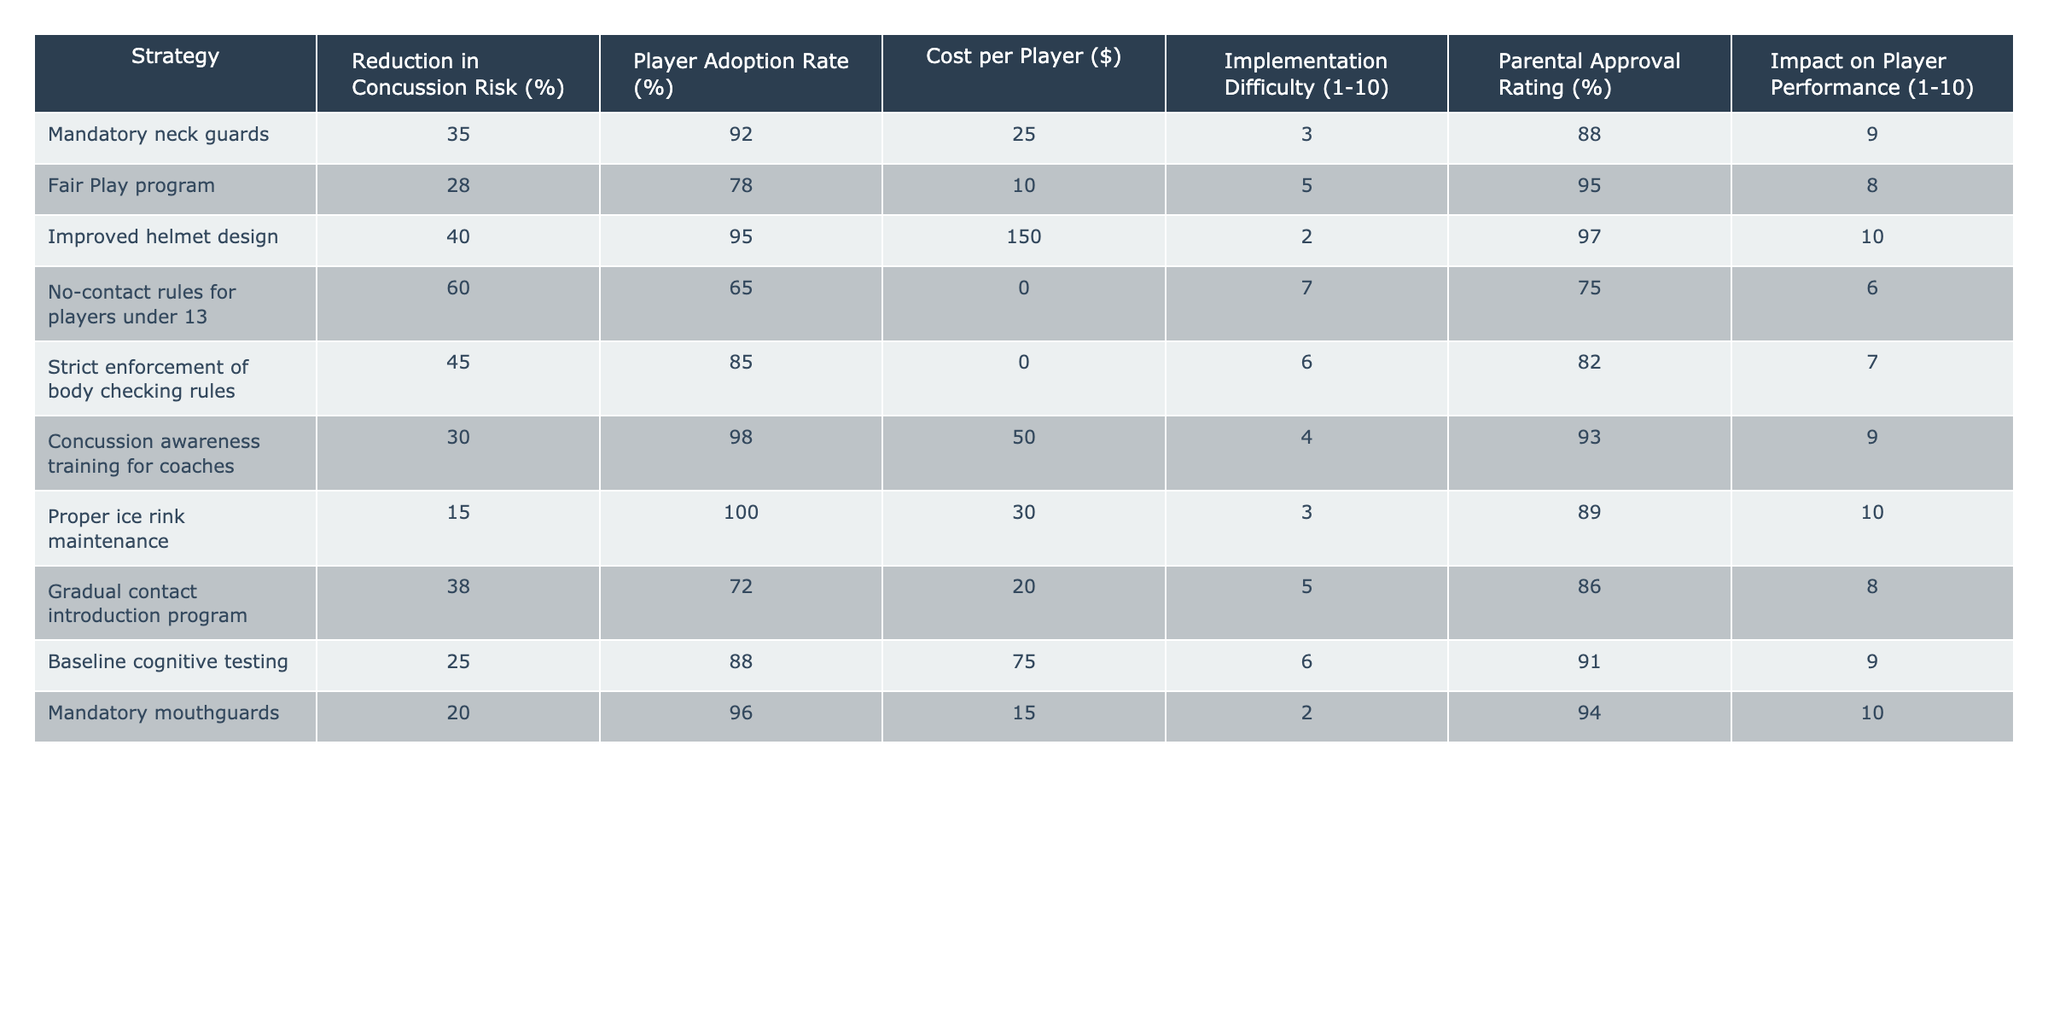What is the concussion risk reduction percentage for improved helmet design? In the table, the "Reduction in Concussion Risk (%)" column shows that improved helmet design has a value of 40%.
Answer: 40% Which strategy has the highest player adoption rate? Looking at the "Player Adoption Rate (%)" column, proper ice rink maintenance has the highest percentage at 100%.
Answer: 100% What is the average cost per player for all strategies? To find the average, we sum the costs ($25 + $10 + $150 + $0 + $0 + $50 + $30 + $20 + $75 + $15 = $ 375) and divide by the number of strategies (10). Therefore, the average cost per player is $375 / 10 = $37.50.
Answer: $37.50 Is the player performance impact rated the same for mandatory mouthguards and the "Fair Play" program? Checking the "Impact on Player Performance (1-10)" column, mandatory mouthguards have a rating of 10 while the "Fair Play" program has a rating of 8. Thus, they are not the same.
Answer: No Which strategy has the lowest implementation difficulty rating and how does it compare to the next? The lowest rating in the "Implementation Difficulty (1-10)" column is 2 for both improved helmet design and mandatory mouthguards. The next lowest is 3 for mandatory neck guards and proper ice rink maintenance. Therefore, both have the same lowest rating.
Answer: Same lowest rating What percentage of parental approval does the "No-contact rules for players under 13" strategy receive? Referring to the "Parental Approval Rating (%)" column, the "No-contact rules for players under 13" shows a parental approval rating of 75%.
Answer: 75% If we compare the concussion risk reduction of the "Gradual contact introduction program" and "Concussion awareness training for coaches," which is higher and by how much? The "Gradual contact introduction program" reduces the risk by 38% and "Concussion awareness training for coaches" by 30%. The difference is 38% - 30% = 8%.
Answer: 8% higher What is the total reduction in concussion risk of all strategies combined? To find the total reduction, we sum all values in the "Reduction in Concussion Risk (%)" column: 35 + 28 + 40 + 60 + 45 + 30 + 15 + 38 + 25 + 20 =  388%.
Answer: 388% How does the adoption rate of neck guards compare to the "Strict enforcement of body checking rules"? The adoption rate for mandatory neck guards is 92%, while for strict enforcement of body checking rules, it is 85%. The neck guards have a higher adoption rate by 7%.
Answer: Higher by 7% Which two strategies have the same impact on player performance? Looking at the "Impact on Player Performance (1-10)" column, both the improved helmet design and mandatory mouthguards have a perfect score of 10.
Answer: Improved helmet design and mandatory mouthguards 